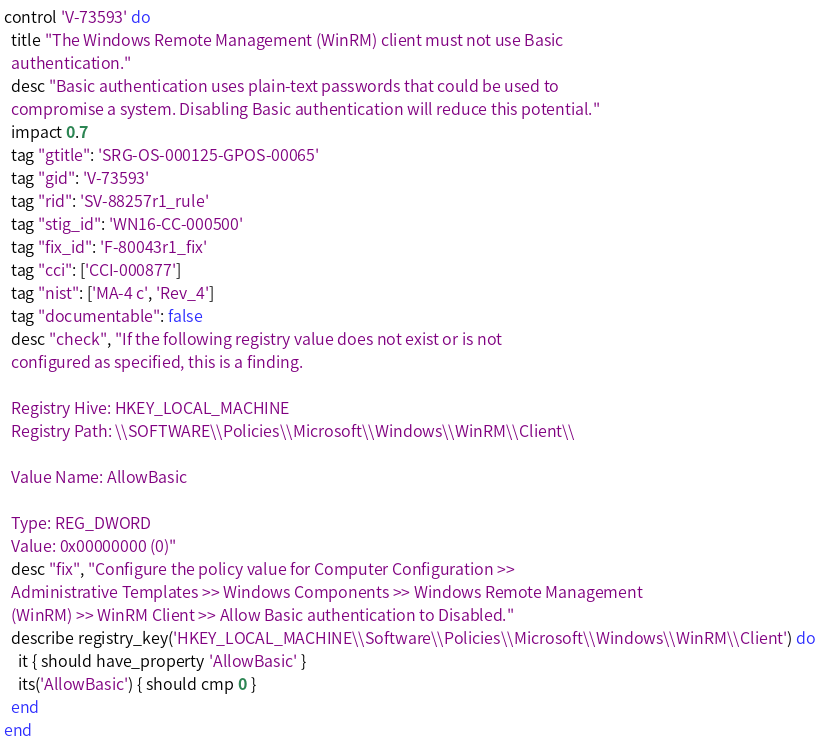Convert code to text. <code><loc_0><loc_0><loc_500><loc_500><_Ruby_>control 'V-73593' do
  title "The Windows Remote Management (WinRM) client must not use Basic
  authentication."
  desc "Basic authentication uses plain-text passwords that could be used to
  compromise a system. Disabling Basic authentication will reduce this potential."
  impact 0.7
  tag "gtitle": 'SRG-OS-000125-GPOS-00065'
  tag "gid": 'V-73593'
  tag "rid": 'SV-88257r1_rule'
  tag "stig_id": 'WN16-CC-000500'
  tag "fix_id": 'F-80043r1_fix'
  tag "cci": ['CCI-000877']
  tag "nist": ['MA-4 c', 'Rev_4']
  tag "documentable": false
  desc "check", "If the following registry value does not exist or is not
  configured as specified, this is a finding.

  Registry Hive: HKEY_LOCAL_MACHINE
  Registry Path: \\SOFTWARE\\Policies\\Microsoft\\Windows\\WinRM\\Client\\

  Value Name: AllowBasic

  Type: REG_DWORD
  Value: 0x00000000 (0)"
  desc "fix", "Configure the policy value for Computer Configuration >>
  Administrative Templates >> Windows Components >> Windows Remote Management
  (WinRM) >> WinRM Client >> Allow Basic authentication to Disabled."
  describe registry_key('HKEY_LOCAL_MACHINE\\Software\\Policies\\Microsoft\\Windows\\WinRM\\Client') do
    it { should have_property 'AllowBasic' }
    its('AllowBasic') { should cmp 0 }
  end
end
</code> 